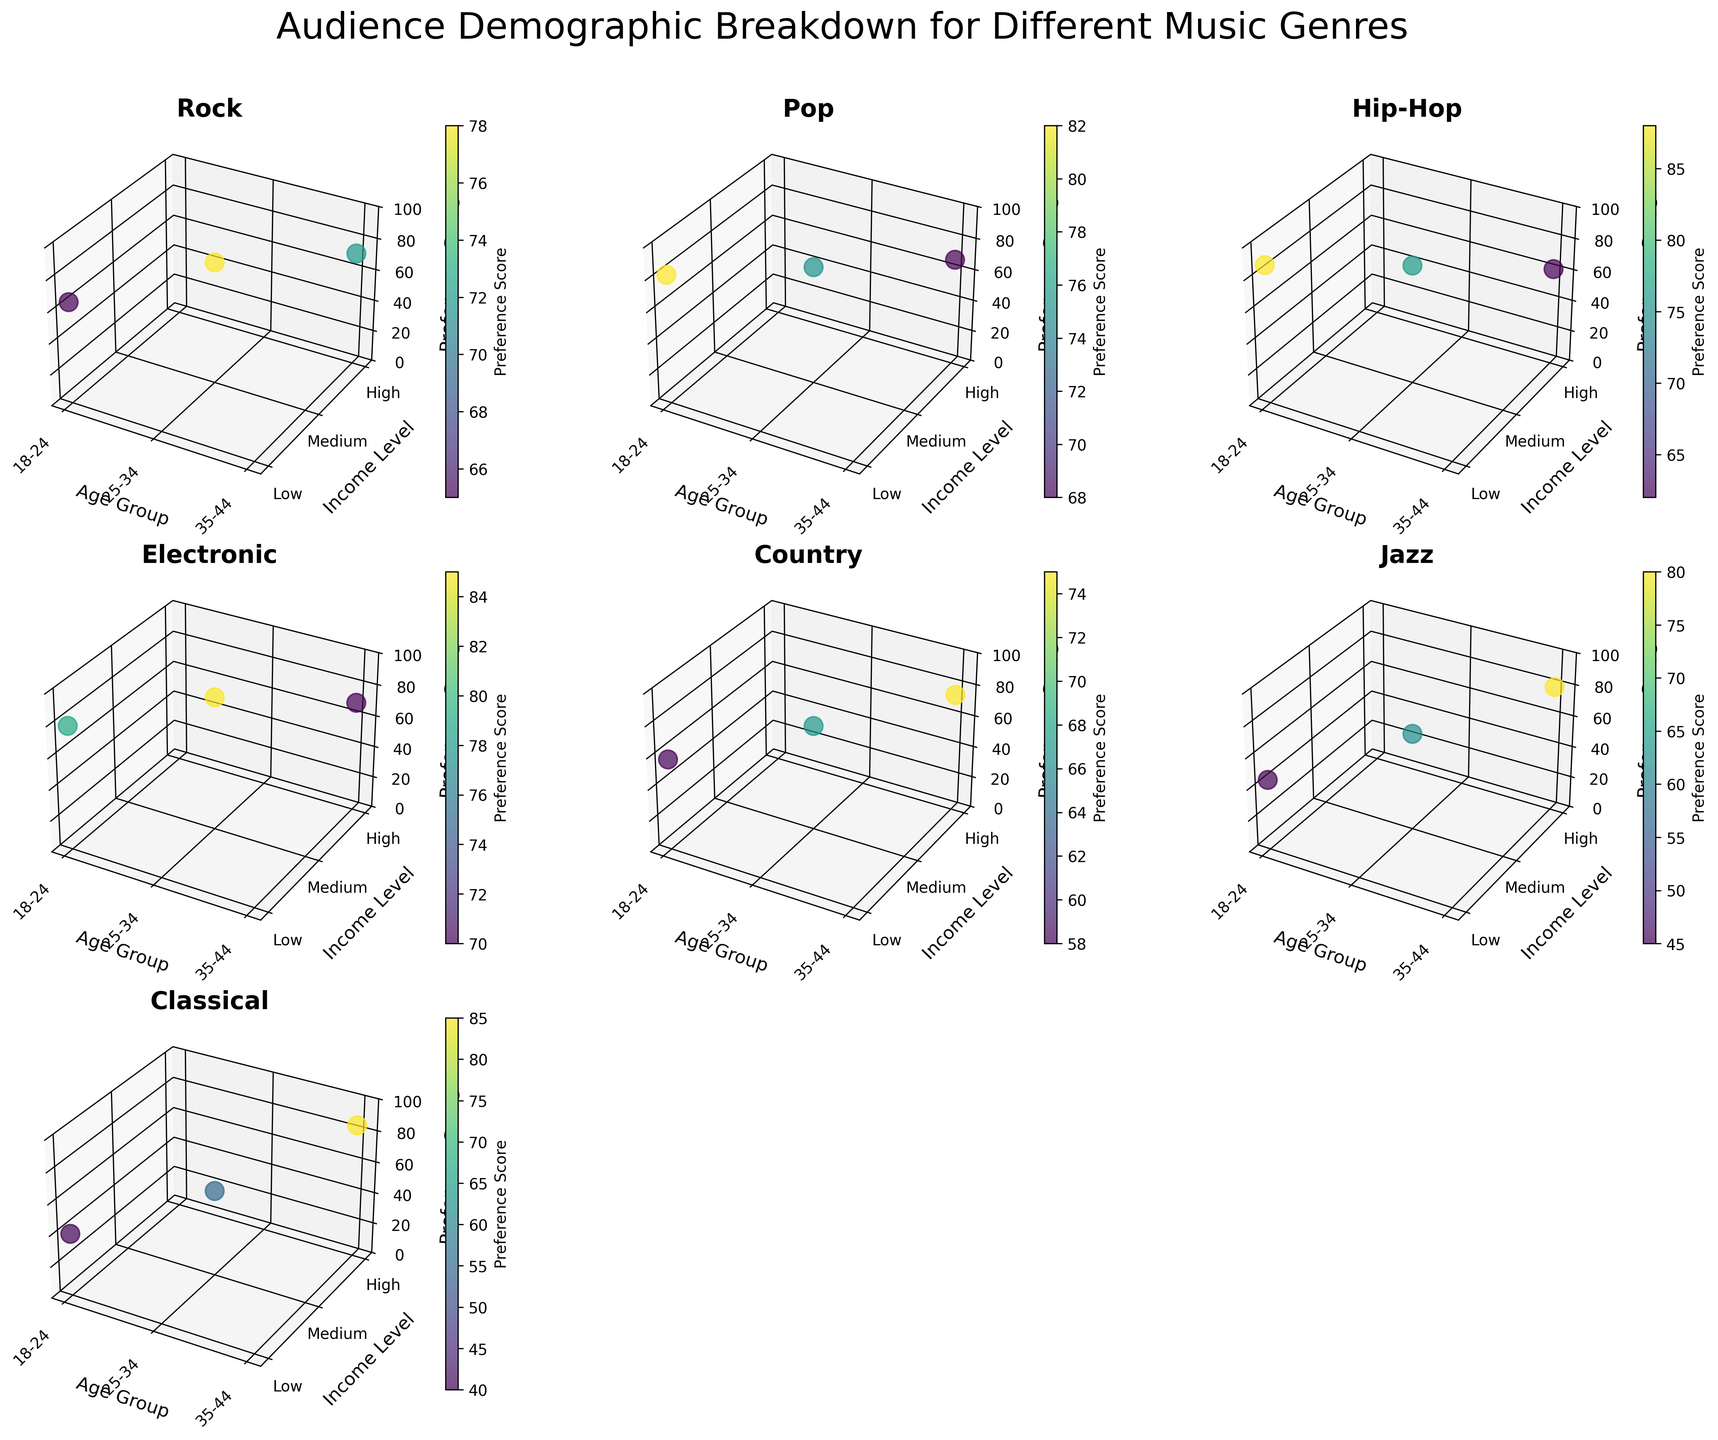What's the title of the figure? The title is found at the top of the figure and is a textual element summarizing the overall content.
Answer: Audience Demographic Breakdown for Different Music Genres Which genre shows the highest preference score for the 18-24 age group? This can be found by looking at the highest z-value for each genre's subplot under the 18-24 age group.
Answer: Hip-Hop What is the income level with the highest preference score in the Pop genre? In the Pop genre subplot, identify the highest z-value on the vertical axis and locate its corresponding y-axis value for income level.
Answer: Low How do the preference scores for Classical and Jazz compare for the 35-44 age group? Check the z-values for the 35-44 age group in both the Classical and Jazz subplots and compare them.
Answer: Classical: 85, Jazz: 80; Classical is higher Which genre shows the least variation in preference scores across different age groups and income levels? Look for the subplot where the z-values are most stable and show the least fluctuation across the x and y axes.
Answer: Country What is the average preference score of the Electronic genre across all age groups and income levels? Calculate the average by summing the z-values for the Electronic genre and dividing by the number of data points (3).
Answer: (79 + 85 + 70) / 3 = 78 Does the Rock genre have higher preference scores for higher income levels? Check the z-values for Rock under different income levels to see if they increase as the income level increases.
Answer: No, Medium has the highest Compare the preference scores for 25-34 age group across all genres. Which genre has the highest score? Identify the z-values for the 25-34 age group in each genre's subplot and find the maximum.
Answer: Electronic Which genre has a preference score above 80 for any age group? Scan each subplot for z-values above 80 and note which genre they belong to.
Answer: Pop, Hip-Hop, Classical What is the difference in preference scores between Low and High income levels in the Jazz genre for the 35-44 age group? Subtract the z-value for Low income from the z-value for High income in the Jazz genre for the 35-44 age group.
Answer: 80 - 45 = 35 